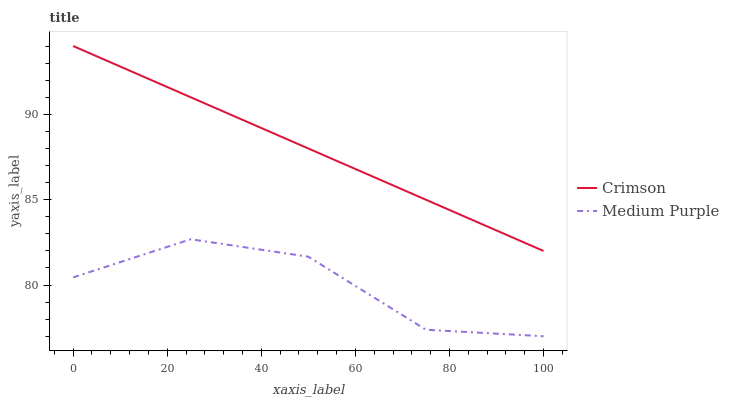Does Medium Purple have the minimum area under the curve?
Answer yes or no. Yes. Does Crimson have the maximum area under the curve?
Answer yes or no. Yes. Does Medium Purple have the maximum area under the curve?
Answer yes or no. No. Is Crimson the smoothest?
Answer yes or no. Yes. Is Medium Purple the roughest?
Answer yes or no. Yes. Is Medium Purple the smoothest?
Answer yes or no. No. Does Medium Purple have the lowest value?
Answer yes or no. Yes. Does Crimson have the highest value?
Answer yes or no. Yes. Does Medium Purple have the highest value?
Answer yes or no. No. Is Medium Purple less than Crimson?
Answer yes or no. Yes. Is Crimson greater than Medium Purple?
Answer yes or no. Yes. Does Medium Purple intersect Crimson?
Answer yes or no. No. 